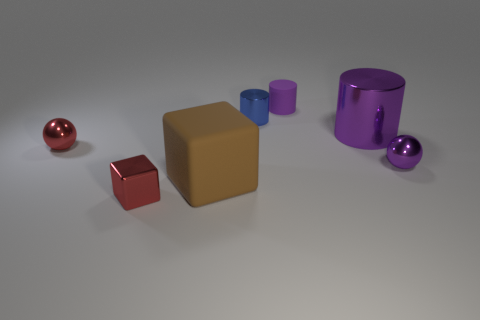Subtract all tiny cylinders. How many cylinders are left? 1 Add 1 tiny blue metallic balls. How many objects exist? 8 Subtract all cubes. How many objects are left? 5 Subtract 2 purple cylinders. How many objects are left? 5 Subtract all purple balls. Subtract all red balls. How many objects are left? 5 Add 6 tiny red metal things. How many tiny red metal things are left? 8 Add 2 gray rubber blocks. How many gray rubber blocks exist? 2 